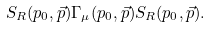Convert formula to latex. <formula><loc_0><loc_0><loc_500><loc_500>S _ { R } ( p _ { 0 } , \vec { p } ) \Gamma _ { \mu } ( p _ { 0 } , \vec { p } ) S _ { R } ( p _ { 0 } , \vec { p } ) .</formula> 